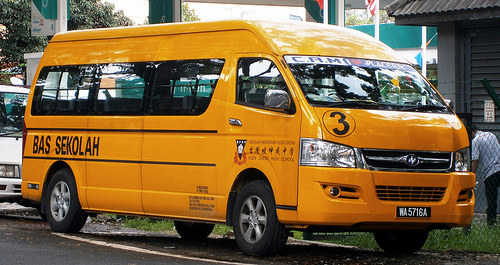<image>
Can you confirm if the van is in front of the man? Yes. The van is positioned in front of the man, appearing closer to the camera viewpoint. 